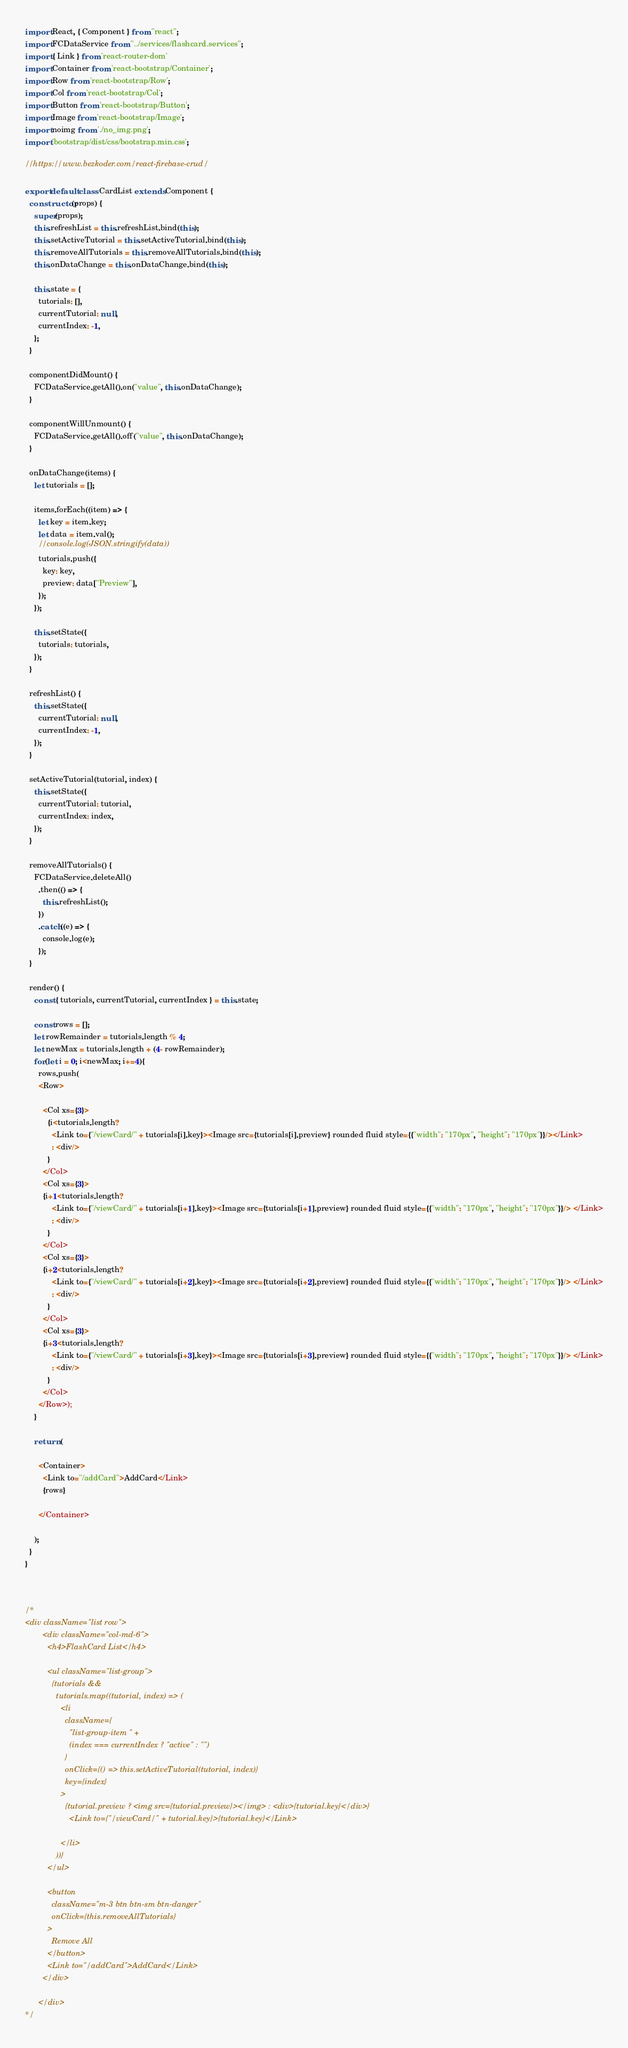Convert code to text. <code><loc_0><loc_0><loc_500><loc_500><_JavaScript_>import React, { Component } from "react";
import FCDataService from "../services/flashcard.services";
import { Link } from 'react-router-dom'
import Container from 'react-bootstrap/Container';
import Row from 'react-bootstrap/Row';
import Col from 'react-bootstrap/Col';
import Button from 'react-bootstrap/Button';
import Image from 'react-bootstrap/Image';
import noimg from './no_img.png';
import 'bootstrap/dist/css/bootstrap.min.css';

//https://www.bezkoder.com/react-firebase-crud/

export default class CardList extends Component {
  constructor(props) {
    super(props);
    this.refreshList = this.refreshList.bind(this);
    this.setActiveTutorial = this.setActiveTutorial.bind(this);
    this.removeAllTutorials = this.removeAllTutorials.bind(this);
    this.onDataChange = this.onDataChange.bind(this);

    this.state = {
      tutorials: [],
      currentTutorial: null,
      currentIndex: -1,
    };
  }

  componentDidMount() {
    FCDataService.getAll().on("value", this.onDataChange);
  }

  componentWillUnmount() {
    FCDataService.getAll().off("value", this.onDataChange);
  }

  onDataChange(items) {
    let tutorials = [];

    items.forEach((item) => {
      let key = item.key;
      let data = item.val();
      //console.log(JSON.stringify(data))
      tutorials.push({
        key: key,
        preview: data["Preview"],
      });
    });

    this.setState({
      tutorials: tutorials,
    });
  }

  refreshList() {
    this.setState({
      currentTutorial: null,
      currentIndex: -1,
    });
  }

  setActiveTutorial(tutorial, index) {
    this.setState({
      currentTutorial: tutorial,
      currentIndex: index,
    });
  }

  removeAllTutorials() {
    FCDataService.deleteAll()
      .then(() => {
        this.refreshList();
      })
      .catch((e) => {
        console.log(e);
      });
  }

  render() {
    const { tutorials, currentTutorial, currentIndex } = this.state;

    const rows = [];
    let rowRemainder = tutorials.length % 4;
    let newMax = tutorials.length + (4- rowRemainder);
    for(let i = 0; i<newMax; i+=4){
      rows.push(
      <Row>
        
        <Col xs={3}>
          {i<tutorials.length? 
            <Link to={"/viewCard/" + tutorials[i].key}><Image src={tutorials[i].preview} rounded fluid style={{"width": "170px", "height": "170px"}}/></Link> 
            : <div/>
          }
        </Col>
        <Col xs={3}>
        {i+1<tutorials.length? 
            <Link to={"/viewCard/" + tutorials[i+1].key}><Image src={tutorials[i+1].preview} rounded fluid style={{"width": "170px", "height": "170px"}}/> </Link>
            : <div/>
          }
        </Col>
        <Col xs={3}>
        {i+2<tutorials.length? 
            <Link to={"/viewCard/" + tutorials[i+2].key}><Image src={tutorials[i+2].preview} rounded fluid style={{"width": "170px", "height": "170px"}}/> </Link>
            : <div/>
          }
        </Col>
        <Col xs={3}>
        {i+3<tutorials.length? 
            <Link to={"/viewCard/" + tutorials[i+3].key}><Image src={tutorials[i+3].preview} rounded fluid style={{"width": "170px", "height": "170px"}}/> </Link>
            : <div/>
          }
        </Col>
      </Row>);
    }

    return (

      <Container>
        <Link to="/addCard">AddCard</Link>
        {rows}
        
      </Container>

    );
  }
}



/*
<div className="list row">
        <div className="col-md-6">
          <h4>FlashCard List</h4>

          <ul className="list-group">
            {tutorials &&
              tutorials.map((tutorial, index) => (
                <li
                  className={
                    "list-group-item " +
                    (index === currentIndex ? "active" : "")
                  }
                  onClick={() => this.setActiveTutorial(tutorial, index)}
                  key={index}
                >
                  {tutorial.preview ? <img src={tutorial.preview}></img> : <div>{tutorial.key}</div>}
                    <Link to={"/viewCard/" + tutorial.key}>{tutorial.key}</Link>
                  
                </li>
              ))}
          </ul>

          <button
            className="m-3 btn btn-sm btn-danger"
            onClick={this.removeAllTutorials}
          >
            Remove All
          </button>
          <Link to="/addCard">AddCard</Link>
        </div>
        
      </div>
*/</code> 